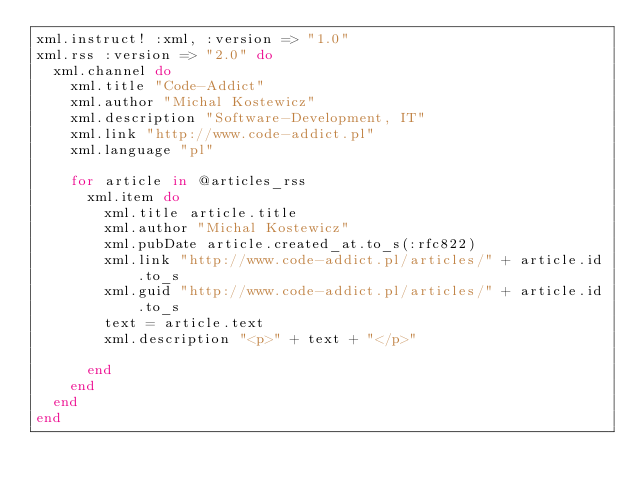Convert code to text. <code><loc_0><loc_0><loc_500><loc_500><_Ruby_>xml.instruct! :xml, :version => "1.0"
xml.rss :version => "2.0" do
  xml.channel do
    xml.title "Code-Addict"
    xml.author "Michal Kostewicz"
    xml.description "Software-Development, IT"
    xml.link "http://www.code-addict.pl"
    xml.language "pl"

    for article in @articles_rss
      xml.item do
        xml.title article.title
        xml.author "Michal Kostewicz"
        xml.pubDate article.created_at.to_s(:rfc822)
        xml.link "http://www.code-addict.pl/articles/" + article.id.to_s
        xml.guid "http://www.code-addict.pl/articles/" + article.id.to_s
        text = article.text		
        xml.description "<p>" + text + "</p>"

      end
    end
  end
end</code> 